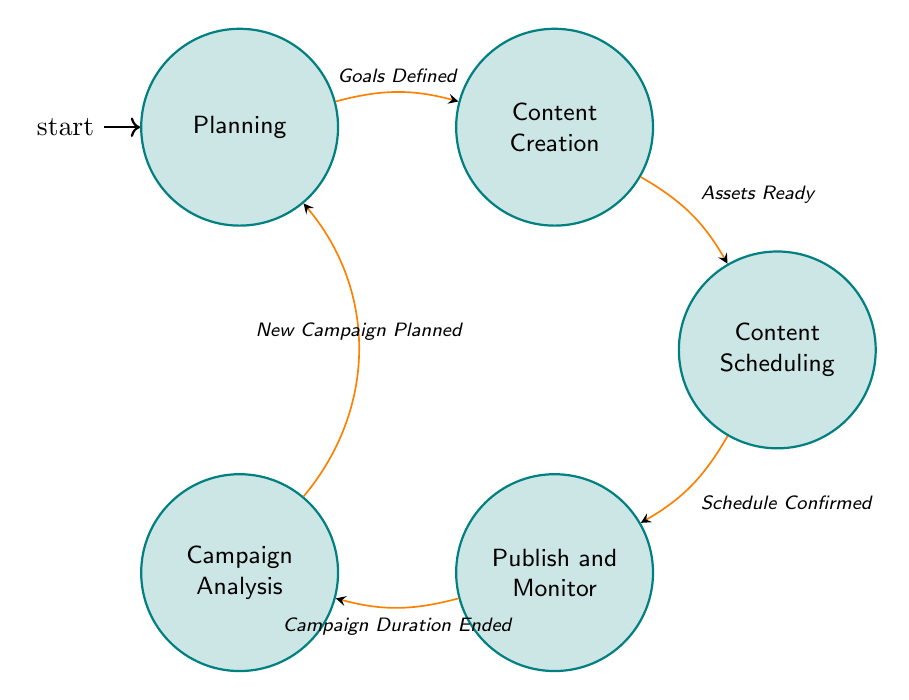What is the starting state of the diagram? The starting state is indicated by the initial node in the diagram, which is "Planning."
Answer: Planning How many states are present in the machine? By counting the nodes in the diagram, we see there are five states: Planning, Content Creation, Content Scheduling, Publish and Monitor, and Campaign Analysis.
Answer: 5 Which state comes after "Content Creation"? The arrow indicates the transition from "Content Creation" to "Content Scheduling," showing that it directly follows.
Answer: Content Scheduling What condition must be met to transition from "Publish and Monitor" to "Campaign Analysis"? The diagram specifies the condition required for this transition, which is "Campaign Duration Ended."
Answer: Campaign Duration Ended What are the activities listed under the "Planning" state? By examining the contents of the "Planning" node, the activities are "Define Goals," "Identify Target Audience," and "Select Platforms."
Answer: Define Goals, Identify Target Audience, Select Platforms If the new campaign is planned, which state will the flow return to? The transition indicates that after "Campaign Analysis," if "New Campaign Planned," the flow returns to the "Planning" state.
Answer: Planning How many transitions are illustrated in the diagram? Counting the arrows that connect the states, we find there are four transitions present in the diagram.
Answer: 4 What is the final state after completing all transitions? Following the flow from the initial state through all transitions leads to the "Campaign Analysis" state.
Answer: Campaign Analysis What is the condition to move from "Content Scheduling" to "Publish and Monitor"? The condition for this transition is clearly marked as "Schedule Confirmed," required to proceed to the next state.
Answer: Schedule Confirmed 